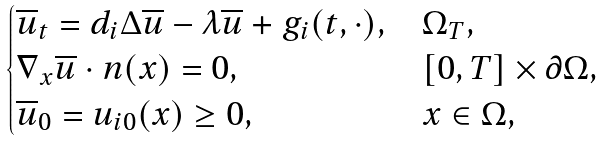Convert formula to latex. <formula><loc_0><loc_0><loc_500><loc_500>\begin{cases} \overline { u } _ { t } = d _ { i } \Delta \overline { u } - \lambda \overline { u } + g _ { i } ( t , \cdot ) , & \Omega _ { T } , \\ \nabla _ { x } \overline { u } \cdot n ( x ) = 0 , & [ 0 , T ] \times \partial \Omega , \\ \overline { u } _ { 0 } = u _ { i 0 } ( x ) \geq 0 , & x \in \Omega , \end{cases}</formula> 